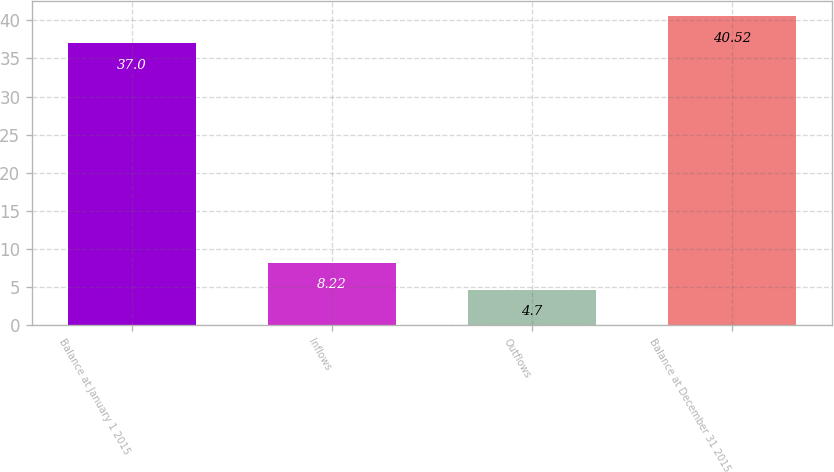<chart> <loc_0><loc_0><loc_500><loc_500><bar_chart><fcel>Balance at January 1 2015<fcel>Inflows<fcel>Outflows<fcel>Balance at December 31 2015<nl><fcel>37<fcel>8.22<fcel>4.7<fcel>40.52<nl></chart> 